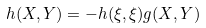<formula> <loc_0><loc_0><loc_500><loc_500>h ( X , Y ) = - h ( \xi , \xi ) g ( X , Y )</formula> 